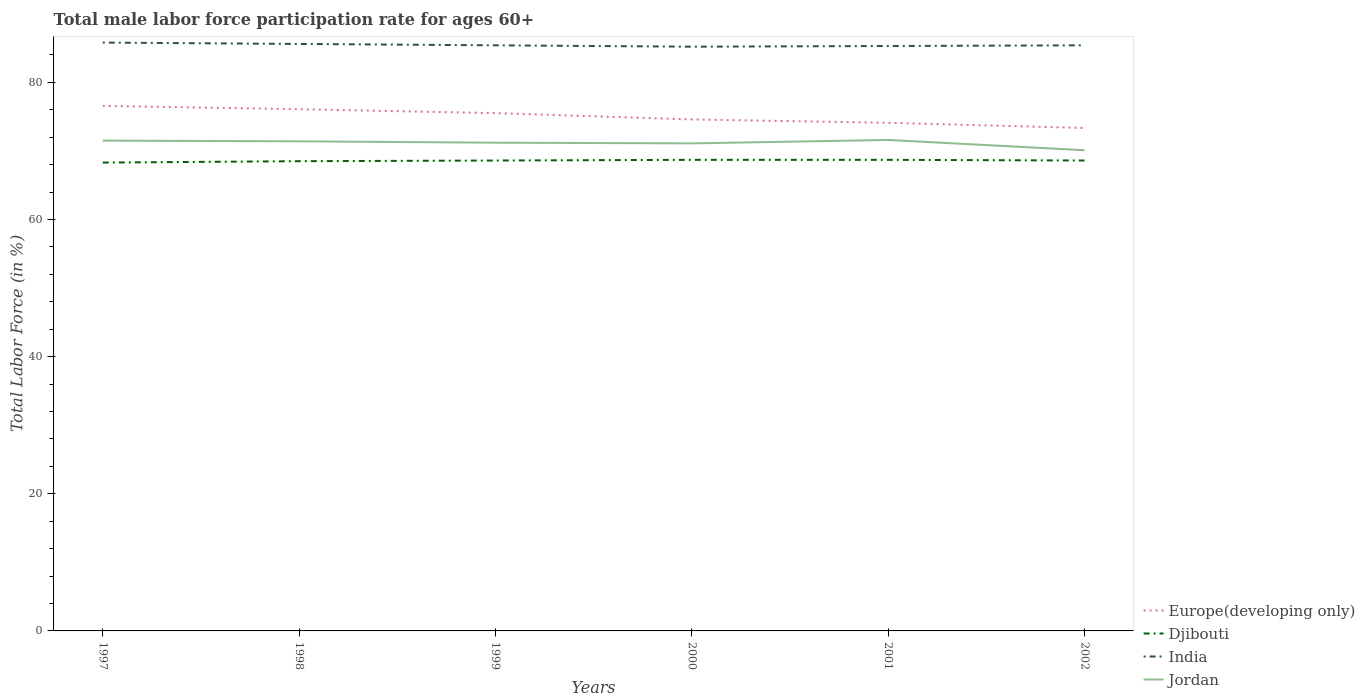How many different coloured lines are there?
Your answer should be compact. 4. Is the number of lines equal to the number of legend labels?
Provide a succinct answer. Yes. Across all years, what is the maximum male labor force participation rate in India?
Give a very brief answer. 85.2. In which year was the male labor force participation rate in Djibouti maximum?
Give a very brief answer. 1997. What is the total male labor force participation rate in Djibouti in the graph?
Provide a succinct answer. -0.1. What is the difference between the highest and the second highest male labor force participation rate in India?
Provide a short and direct response. 0.6. How many lines are there?
Give a very brief answer. 4. How many years are there in the graph?
Offer a very short reply. 6. Are the values on the major ticks of Y-axis written in scientific E-notation?
Your answer should be very brief. No. Does the graph contain any zero values?
Provide a short and direct response. No. Does the graph contain grids?
Provide a short and direct response. No. Where does the legend appear in the graph?
Ensure brevity in your answer.  Bottom right. What is the title of the graph?
Offer a terse response. Total male labor force participation rate for ages 60+. What is the label or title of the X-axis?
Offer a terse response. Years. What is the Total Labor Force (in %) of Europe(developing only) in 1997?
Keep it short and to the point. 76.57. What is the Total Labor Force (in %) of Djibouti in 1997?
Keep it short and to the point. 68.3. What is the Total Labor Force (in %) in India in 1997?
Your answer should be very brief. 85.8. What is the Total Labor Force (in %) of Jordan in 1997?
Your answer should be compact. 71.5. What is the Total Labor Force (in %) of Europe(developing only) in 1998?
Your answer should be very brief. 76.08. What is the Total Labor Force (in %) of Djibouti in 1998?
Provide a succinct answer. 68.5. What is the Total Labor Force (in %) in India in 1998?
Make the answer very short. 85.6. What is the Total Labor Force (in %) in Jordan in 1998?
Keep it short and to the point. 71.4. What is the Total Labor Force (in %) of Europe(developing only) in 1999?
Provide a succinct answer. 75.51. What is the Total Labor Force (in %) of Djibouti in 1999?
Your response must be concise. 68.6. What is the Total Labor Force (in %) of India in 1999?
Provide a succinct answer. 85.4. What is the Total Labor Force (in %) in Jordan in 1999?
Keep it short and to the point. 71.2. What is the Total Labor Force (in %) in Europe(developing only) in 2000?
Your response must be concise. 74.59. What is the Total Labor Force (in %) in Djibouti in 2000?
Your response must be concise. 68.7. What is the Total Labor Force (in %) of India in 2000?
Make the answer very short. 85.2. What is the Total Labor Force (in %) in Jordan in 2000?
Your answer should be very brief. 71.1. What is the Total Labor Force (in %) of Europe(developing only) in 2001?
Make the answer very short. 74.1. What is the Total Labor Force (in %) of Djibouti in 2001?
Provide a short and direct response. 68.7. What is the Total Labor Force (in %) in India in 2001?
Offer a very short reply. 85.3. What is the Total Labor Force (in %) in Jordan in 2001?
Ensure brevity in your answer.  71.6. What is the Total Labor Force (in %) in Europe(developing only) in 2002?
Give a very brief answer. 73.34. What is the Total Labor Force (in %) in Djibouti in 2002?
Your answer should be compact. 68.6. What is the Total Labor Force (in %) of India in 2002?
Your answer should be very brief. 85.4. What is the Total Labor Force (in %) of Jordan in 2002?
Provide a short and direct response. 70.1. Across all years, what is the maximum Total Labor Force (in %) in Europe(developing only)?
Provide a short and direct response. 76.57. Across all years, what is the maximum Total Labor Force (in %) of Djibouti?
Offer a very short reply. 68.7. Across all years, what is the maximum Total Labor Force (in %) of India?
Offer a very short reply. 85.8. Across all years, what is the maximum Total Labor Force (in %) of Jordan?
Your answer should be very brief. 71.6. Across all years, what is the minimum Total Labor Force (in %) in Europe(developing only)?
Make the answer very short. 73.34. Across all years, what is the minimum Total Labor Force (in %) of Djibouti?
Offer a very short reply. 68.3. Across all years, what is the minimum Total Labor Force (in %) in India?
Provide a succinct answer. 85.2. Across all years, what is the minimum Total Labor Force (in %) in Jordan?
Offer a very short reply. 70.1. What is the total Total Labor Force (in %) of Europe(developing only) in the graph?
Your answer should be very brief. 450.2. What is the total Total Labor Force (in %) in Djibouti in the graph?
Your answer should be compact. 411.4. What is the total Total Labor Force (in %) of India in the graph?
Your answer should be compact. 512.7. What is the total Total Labor Force (in %) of Jordan in the graph?
Provide a short and direct response. 426.9. What is the difference between the Total Labor Force (in %) in Europe(developing only) in 1997 and that in 1998?
Offer a very short reply. 0.48. What is the difference between the Total Labor Force (in %) in India in 1997 and that in 1998?
Provide a short and direct response. 0.2. What is the difference between the Total Labor Force (in %) in Europe(developing only) in 1997 and that in 1999?
Offer a very short reply. 1.05. What is the difference between the Total Labor Force (in %) in Djibouti in 1997 and that in 1999?
Give a very brief answer. -0.3. What is the difference between the Total Labor Force (in %) in Jordan in 1997 and that in 1999?
Make the answer very short. 0.3. What is the difference between the Total Labor Force (in %) in Europe(developing only) in 1997 and that in 2000?
Provide a succinct answer. 1.98. What is the difference between the Total Labor Force (in %) in Europe(developing only) in 1997 and that in 2001?
Your answer should be very brief. 2.47. What is the difference between the Total Labor Force (in %) in Djibouti in 1997 and that in 2001?
Provide a short and direct response. -0.4. What is the difference between the Total Labor Force (in %) in India in 1997 and that in 2001?
Make the answer very short. 0.5. What is the difference between the Total Labor Force (in %) in Jordan in 1997 and that in 2001?
Your answer should be very brief. -0.1. What is the difference between the Total Labor Force (in %) in Europe(developing only) in 1997 and that in 2002?
Offer a very short reply. 3.22. What is the difference between the Total Labor Force (in %) of Jordan in 1997 and that in 2002?
Offer a very short reply. 1.4. What is the difference between the Total Labor Force (in %) in Europe(developing only) in 1998 and that in 1999?
Your answer should be compact. 0.57. What is the difference between the Total Labor Force (in %) in Djibouti in 1998 and that in 1999?
Your answer should be very brief. -0.1. What is the difference between the Total Labor Force (in %) in India in 1998 and that in 1999?
Provide a short and direct response. 0.2. What is the difference between the Total Labor Force (in %) of Europe(developing only) in 1998 and that in 2000?
Make the answer very short. 1.49. What is the difference between the Total Labor Force (in %) in India in 1998 and that in 2000?
Give a very brief answer. 0.4. What is the difference between the Total Labor Force (in %) in Jordan in 1998 and that in 2000?
Offer a very short reply. 0.3. What is the difference between the Total Labor Force (in %) of Europe(developing only) in 1998 and that in 2001?
Ensure brevity in your answer.  1.98. What is the difference between the Total Labor Force (in %) in Djibouti in 1998 and that in 2001?
Your answer should be very brief. -0.2. What is the difference between the Total Labor Force (in %) in India in 1998 and that in 2001?
Provide a succinct answer. 0.3. What is the difference between the Total Labor Force (in %) of Jordan in 1998 and that in 2001?
Provide a succinct answer. -0.2. What is the difference between the Total Labor Force (in %) of Europe(developing only) in 1998 and that in 2002?
Offer a terse response. 2.74. What is the difference between the Total Labor Force (in %) in Djibouti in 1998 and that in 2002?
Provide a short and direct response. -0.1. What is the difference between the Total Labor Force (in %) of India in 1998 and that in 2002?
Keep it short and to the point. 0.2. What is the difference between the Total Labor Force (in %) of Europe(developing only) in 1999 and that in 2000?
Ensure brevity in your answer.  0.92. What is the difference between the Total Labor Force (in %) of Jordan in 1999 and that in 2000?
Offer a very short reply. 0.1. What is the difference between the Total Labor Force (in %) of Europe(developing only) in 1999 and that in 2001?
Make the answer very short. 1.41. What is the difference between the Total Labor Force (in %) in India in 1999 and that in 2001?
Give a very brief answer. 0.1. What is the difference between the Total Labor Force (in %) of Jordan in 1999 and that in 2001?
Your answer should be very brief. -0.4. What is the difference between the Total Labor Force (in %) in Europe(developing only) in 1999 and that in 2002?
Give a very brief answer. 2.17. What is the difference between the Total Labor Force (in %) in India in 1999 and that in 2002?
Provide a succinct answer. 0. What is the difference between the Total Labor Force (in %) of Europe(developing only) in 2000 and that in 2001?
Keep it short and to the point. 0.49. What is the difference between the Total Labor Force (in %) in Djibouti in 2000 and that in 2001?
Your answer should be very brief. 0. What is the difference between the Total Labor Force (in %) in India in 2000 and that in 2001?
Provide a succinct answer. -0.1. What is the difference between the Total Labor Force (in %) in Europe(developing only) in 2000 and that in 2002?
Offer a terse response. 1.25. What is the difference between the Total Labor Force (in %) of Jordan in 2000 and that in 2002?
Your answer should be very brief. 1. What is the difference between the Total Labor Force (in %) of Europe(developing only) in 2001 and that in 2002?
Provide a succinct answer. 0.75. What is the difference between the Total Labor Force (in %) in Djibouti in 2001 and that in 2002?
Your answer should be compact. 0.1. What is the difference between the Total Labor Force (in %) of India in 2001 and that in 2002?
Ensure brevity in your answer.  -0.1. What is the difference between the Total Labor Force (in %) of Europe(developing only) in 1997 and the Total Labor Force (in %) of Djibouti in 1998?
Your response must be concise. 8.07. What is the difference between the Total Labor Force (in %) of Europe(developing only) in 1997 and the Total Labor Force (in %) of India in 1998?
Offer a very short reply. -9.03. What is the difference between the Total Labor Force (in %) of Europe(developing only) in 1997 and the Total Labor Force (in %) of Jordan in 1998?
Offer a terse response. 5.17. What is the difference between the Total Labor Force (in %) in Djibouti in 1997 and the Total Labor Force (in %) in India in 1998?
Your answer should be very brief. -17.3. What is the difference between the Total Labor Force (in %) in Djibouti in 1997 and the Total Labor Force (in %) in Jordan in 1998?
Offer a terse response. -3.1. What is the difference between the Total Labor Force (in %) of Europe(developing only) in 1997 and the Total Labor Force (in %) of Djibouti in 1999?
Provide a succinct answer. 7.97. What is the difference between the Total Labor Force (in %) in Europe(developing only) in 1997 and the Total Labor Force (in %) in India in 1999?
Keep it short and to the point. -8.83. What is the difference between the Total Labor Force (in %) in Europe(developing only) in 1997 and the Total Labor Force (in %) in Jordan in 1999?
Provide a short and direct response. 5.37. What is the difference between the Total Labor Force (in %) in Djibouti in 1997 and the Total Labor Force (in %) in India in 1999?
Your answer should be very brief. -17.1. What is the difference between the Total Labor Force (in %) of India in 1997 and the Total Labor Force (in %) of Jordan in 1999?
Keep it short and to the point. 14.6. What is the difference between the Total Labor Force (in %) of Europe(developing only) in 1997 and the Total Labor Force (in %) of Djibouti in 2000?
Ensure brevity in your answer.  7.87. What is the difference between the Total Labor Force (in %) in Europe(developing only) in 1997 and the Total Labor Force (in %) in India in 2000?
Keep it short and to the point. -8.63. What is the difference between the Total Labor Force (in %) in Europe(developing only) in 1997 and the Total Labor Force (in %) in Jordan in 2000?
Offer a very short reply. 5.47. What is the difference between the Total Labor Force (in %) of Djibouti in 1997 and the Total Labor Force (in %) of India in 2000?
Your response must be concise. -16.9. What is the difference between the Total Labor Force (in %) of Djibouti in 1997 and the Total Labor Force (in %) of Jordan in 2000?
Offer a very short reply. -2.8. What is the difference between the Total Labor Force (in %) of Europe(developing only) in 1997 and the Total Labor Force (in %) of Djibouti in 2001?
Make the answer very short. 7.87. What is the difference between the Total Labor Force (in %) in Europe(developing only) in 1997 and the Total Labor Force (in %) in India in 2001?
Your response must be concise. -8.73. What is the difference between the Total Labor Force (in %) of Europe(developing only) in 1997 and the Total Labor Force (in %) of Jordan in 2001?
Your answer should be compact. 4.97. What is the difference between the Total Labor Force (in %) of Europe(developing only) in 1997 and the Total Labor Force (in %) of Djibouti in 2002?
Your response must be concise. 7.97. What is the difference between the Total Labor Force (in %) in Europe(developing only) in 1997 and the Total Labor Force (in %) in India in 2002?
Provide a short and direct response. -8.83. What is the difference between the Total Labor Force (in %) of Europe(developing only) in 1997 and the Total Labor Force (in %) of Jordan in 2002?
Keep it short and to the point. 6.47. What is the difference between the Total Labor Force (in %) in Djibouti in 1997 and the Total Labor Force (in %) in India in 2002?
Ensure brevity in your answer.  -17.1. What is the difference between the Total Labor Force (in %) of India in 1997 and the Total Labor Force (in %) of Jordan in 2002?
Your response must be concise. 15.7. What is the difference between the Total Labor Force (in %) of Europe(developing only) in 1998 and the Total Labor Force (in %) of Djibouti in 1999?
Ensure brevity in your answer.  7.48. What is the difference between the Total Labor Force (in %) in Europe(developing only) in 1998 and the Total Labor Force (in %) in India in 1999?
Your response must be concise. -9.32. What is the difference between the Total Labor Force (in %) in Europe(developing only) in 1998 and the Total Labor Force (in %) in Jordan in 1999?
Your answer should be compact. 4.88. What is the difference between the Total Labor Force (in %) of Djibouti in 1998 and the Total Labor Force (in %) of India in 1999?
Give a very brief answer. -16.9. What is the difference between the Total Labor Force (in %) in Djibouti in 1998 and the Total Labor Force (in %) in Jordan in 1999?
Your response must be concise. -2.7. What is the difference between the Total Labor Force (in %) of India in 1998 and the Total Labor Force (in %) of Jordan in 1999?
Keep it short and to the point. 14.4. What is the difference between the Total Labor Force (in %) in Europe(developing only) in 1998 and the Total Labor Force (in %) in Djibouti in 2000?
Give a very brief answer. 7.38. What is the difference between the Total Labor Force (in %) in Europe(developing only) in 1998 and the Total Labor Force (in %) in India in 2000?
Your answer should be compact. -9.12. What is the difference between the Total Labor Force (in %) of Europe(developing only) in 1998 and the Total Labor Force (in %) of Jordan in 2000?
Provide a succinct answer. 4.98. What is the difference between the Total Labor Force (in %) of Djibouti in 1998 and the Total Labor Force (in %) of India in 2000?
Ensure brevity in your answer.  -16.7. What is the difference between the Total Labor Force (in %) of Djibouti in 1998 and the Total Labor Force (in %) of Jordan in 2000?
Offer a very short reply. -2.6. What is the difference between the Total Labor Force (in %) in Europe(developing only) in 1998 and the Total Labor Force (in %) in Djibouti in 2001?
Give a very brief answer. 7.38. What is the difference between the Total Labor Force (in %) of Europe(developing only) in 1998 and the Total Labor Force (in %) of India in 2001?
Provide a short and direct response. -9.22. What is the difference between the Total Labor Force (in %) of Europe(developing only) in 1998 and the Total Labor Force (in %) of Jordan in 2001?
Give a very brief answer. 4.48. What is the difference between the Total Labor Force (in %) in Djibouti in 1998 and the Total Labor Force (in %) in India in 2001?
Your response must be concise. -16.8. What is the difference between the Total Labor Force (in %) of Djibouti in 1998 and the Total Labor Force (in %) of Jordan in 2001?
Make the answer very short. -3.1. What is the difference between the Total Labor Force (in %) in India in 1998 and the Total Labor Force (in %) in Jordan in 2001?
Provide a short and direct response. 14. What is the difference between the Total Labor Force (in %) in Europe(developing only) in 1998 and the Total Labor Force (in %) in Djibouti in 2002?
Your answer should be very brief. 7.48. What is the difference between the Total Labor Force (in %) of Europe(developing only) in 1998 and the Total Labor Force (in %) of India in 2002?
Your answer should be compact. -9.32. What is the difference between the Total Labor Force (in %) of Europe(developing only) in 1998 and the Total Labor Force (in %) of Jordan in 2002?
Give a very brief answer. 5.98. What is the difference between the Total Labor Force (in %) in Djibouti in 1998 and the Total Labor Force (in %) in India in 2002?
Your answer should be compact. -16.9. What is the difference between the Total Labor Force (in %) in Djibouti in 1998 and the Total Labor Force (in %) in Jordan in 2002?
Your answer should be very brief. -1.6. What is the difference between the Total Labor Force (in %) of Europe(developing only) in 1999 and the Total Labor Force (in %) of Djibouti in 2000?
Your response must be concise. 6.81. What is the difference between the Total Labor Force (in %) in Europe(developing only) in 1999 and the Total Labor Force (in %) in India in 2000?
Provide a short and direct response. -9.69. What is the difference between the Total Labor Force (in %) of Europe(developing only) in 1999 and the Total Labor Force (in %) of Jordan in 2000?
Your response must be concise. 4.41. What is the difference between the Total Labor Force (in %) of Djibouti in 1999 and the Total Labor Force (in %) of India in 2000?
Your answer should be very brief. -16.6. What is the difference between the Total Labor Force (in %) of Djibouti in 1999 and the Total Labor Force (in %) of Jordan in 2000?
Ensure brevity in your answer.  -2.5. What is the difference between the Total Labor Force (in %) in Europe(developing only) in 1999 and the Total Labor Force (in %) in Djibouti in 2001?
Give a very brief answer. 6.81. What is the difference between the Total Labor Force (in %) in Europe(developing only) in 1999 and the Total Labor Force (in %) in India in 2001?
Keep it short and to the point. -9.79. What is the difference between the Total Labor Force (in %) in Europe(developing only) in 1999 and the Total Labor Force (in %) in Jordan in 2001?
Offer a very short reply. 3.91. What is the difference between the Total Labor Force (in %) in Djibouti in 1999 and the Total Labor Force (in %) in India in 2001?
Keep it short and to the point. -16.7. What is the difference between the Total Labor Force (in %) in Europe(developing only) in 1999 and the Total Labor Force (in %) in Djibouti in 2002?
Ensure brevity in your answer.  6.91. What is the difference between the Total Labor Force (in %) of Europe(developing only) in 1999 and the Total Labor Force (in %) of India in 2002?
Offer a terse response. -9.89. What is the difference between the Total Labor Force (in %) in Europe(developing only) in 1999 and the Total Labor Force (in %) in Jordan in 2002?
Your answer should be very brief. 5.41. What is the difference between the Total Labor Force (in %) of Djibouti in 1999 and the Total Labor Force (in %) of India in 2002?
Your answer should be very brief. -16.8. What is the difference between the Total Labor Force (in %) of Djibouti in 1999 and the Total Labor Force (in %) of Jordan in 2002?
Keep it short and to the point. -1.5. What is the difference between the Total Labor Force (in %) of India in 1999 and the Total Labor Force (in %) of Jordan in 2002?
Provide a succinct answer. 15.3. What is the difference between the Total Labor Force (in %) of Europe(developing only) in 2000 and the Total Labor Force (in %) of Djibouti in 2001?
Provide a short and direct response. 5.89. What is the difference between the Total Labor Force (in %) of Europe(developing only) in 2000 and the Total Labor Force (in %) of India in 2001?
Provide a succinct answer. -10.71. What is the difference between the Total Labor Force (in %) in Europe(developing only) in 2000 and the Total Labor Force (in %) in Jordan in 2001?
Offer a very short reply. 2.99. What is the difference between the Total Labor Force (in %) of Djibouti in 2000 and the Total Labor Force (in %) of India in 2001?
Your response must be concise. -16.6. What is the difference between the Total Labor Force (in %) in Djibouti in 2000 and the Total Labor Force (in %) in Jordan in 2001?
Offer a terse response. -2.9. What is the difference between the Total Labor Force (in %) of Europe(developing only) in 2000 and the Total Labor Force (in %) of Djibouti in 2002?
Offer a very short reply. 5.99. What is the difference between the Total Labor Force (in %) of Europe(developing only) in 2000 and the Total Labor Force (in %) of India in 2002?
Your response must be concise. -10.81. What is the difference between the Total Labor Force (in %) in Europe(developing only) in 2000 and the Total Labor Force (in %) in Jordan in 2002?
Your response must be concise. 4.49. What is the difference between the Total Labor Force (in %) in Djibouti in 2000 and the Total Labor Force (in %) in India in 2002?
Your answer should be compact. -16.7. What is the difference between the Total Labor Force (in %) of Europe(developing only) in 2001 and the Total Labor Force (in %) of Djibouti in 2002?
Keep it short and to the point. 5.5. What is the difference between the Total Labor Force (in %) of Europe(developing only) in 2001 and the Total Labor Force (in %) of India in 2002?
Offer a very short reply. -11.3. What is the difference between the Total Labor Force (in %) of Europe(developing only) in 2001 and the Total Labor Force (in %) of Jordan in 2002?
Keep it short and to the point. 4. What is the difference between the Total Labor Force (in %) of Djibouti in 2001 and the Total Labor Force (in %) of India in 2002?
Give a very brief answer. -16.7. What is the difference between the Total Labor Force (in %) of India in 2001 and the Total Labor Force (in %) of Jordan in 2002?
Give a very brief answer. 15.2. What is the average Total Labor Force (in %) of Europe(developing only) per year?
Offer a very short reply. 75.03. What is the average Total Labor Force (in %) of Djibouti per year?
Give a very brief answer. 68.57. What is the average Total Labor Force (in %) of India per year?
Provide a short and direct response. 85.45. What is the average Total Labor Force (in %) in Jordan per year?
Make the answer very short. 71.15. In the year 1997, what is the difference between the Total Labor Force (in %) in Europe(developing only) and Total Labor Force (in %) in Djibouti?
Keep it short and to the point. 8.27. In the year 1997, what is the difference between the Total Labor Force (in %) in Europe(developing only) and Total Labor Force (in %) in India?
Your answer should be very brief. -9.23. In the year 1997, what is the difference between the Total Labor Force (in %) in Europe(developing only) and Total Labor Force (in %) in Jordan?
Keep it short and to the point. 5.07. In the year 1997, what is the difference between the Total Labor Force (in %) in Djibouti and Total Labor Force (in %) in India?
Ensure brevity in your answer.  -17.5. In the year 1997, what is the difference between the Total Labor Force (in %) of Djibouti and Total Labor Force (in %) of Jordan?
Your answer should be compact. -3.2. In the year 1998, what is the difference between the Total Labor Force (in %) of Europe(developing only) and Total Labor Force (in %) of Djibouti?
Make the answer very short. 7.58. In the year 1998, what is the difference between the Total Labor Force (in %) in Europe(developing only) and Total Labor Force (in %) in India?
Offer a terse response. -9.52. In the year 1998, what is the difference between the Total Labor Force (in %) in Europe(developing only) and Total Labor Force (in %) in Jordan?
Provide a short and direct response. 4.68. In the year 1998, what is the difference between the Total Labor Force (in %) in Djibouti and Total Labor Force (in %) in India?
Your answer should be very brief. -17.1. In the year 1998, what is the difference between the Total Labor Force (in %) in India and Total Labor Force (in %) in Jordan?
Keep it short and to the point. 14.2. In the year 1999, what is the difference between the Total Labor Force (in %) of Europe(developing only) and Total Labor Force (in %) of Djibouti?
Keep it short and to the point. 6.91. In the year 1999, what is the difference between the Total Labor Force (in %) of Europe(developing only) and Total Labor Force (in %) of India?
Offer a terse response. -9.89. In the year 1999, what is the difference between the Total Labor Force (in %) of Europe(developing only) and Total Labor Force (in %) of Jordan?
Provide a succinct answer. 4.31. In the year 1999, what is the difference between the Total Labor Force (in %) in Djibouti and Total Labor Force (in %) in India?
Ensure brevity in your answer.  -16.8. In the year 2000, what is the difference between the Total Labor Force (in %) of Europe(developing only) and Total Labor Force (in %) of Djibouti?
Your response must be concise. 5.89. In the year 2000, what is the difference between the Total Labor Force (in %) of Europe(developing only) and Total Labor Force (in %) of India?
Offer a very short reply. -10.61. In the year 2000, what is the difference between the Total Labor Force (in %) of Europe(developing only) and Total Labor Force (in %) of Jordan?
Offer a very short reply. 3.49. In the year 2000, what is the difference between the Total Labor Force (in %) in Djibouti and Total Labor Force (in %) in India?
Offer a terse response. -16.5. In the year 2000, what is the difference between the Total Labor Force (in %) of Djibouti and Total Labor Force (in %) of Jordan?
Keep it short and to the point. -2.4. In the year 2000, what is the difference between the Total Labor Force (in %) of India and Total Labor Force (in %) of Jordan?
Offer a terse response. 14.1. In the year 2001, what is the difference between the Total Labor Force (in %) of Europe(developing only) and Total Labor Force (in %) of Djibouti?
Keep it short and to the point. 5.4. In the year 2001, what is the difference between the Total Labor Force (in %) in Europe(developing only) and Total Labor Force (in %) in India?
Ensure brevity in your answer.  -11.2. In the year 2001, what is the difference between the Total Labor Force (in %) in Europe(developing only) and Total Labor Force (in %) in Jordan?
Ensure brevity in your answer.  2.5. In the year 2001, what is the difference between the Total Labor Force (in %) of Djibouti and Total Labor Force (in %) of India?
Offer a terse response. -16.6. In the year 2001, what is the difference between the Total Labor Force (in %) of India and Total Labor Force (in %) of Jordan?
Your response must be concise. 13.7. In the year 2002, what is the difference between the Total Labor Force (in %) in Europe(developing only) and Total Labor Force (in %) in Djibouti?
Provide a short and direct response. 4.74. In the year 2002, what is the difference between the Total Labor Force (in %) in Europe(developing only) and Total Labor Force (in %) in India?
Provide a short and direct response. -12.06. In the year 2002, what is the difference between the Total Labor Force (in %) in Europe(developing only) and Total Labor Force (in %) in Jordan?
Offer a terse response. 3.24. In the year 2002, what is the difference between the Total Labor Force (in %) of Djibouti and Total Labor Force (in %) of India?
Your response must be concise. -16.8. What is the ratio of the Total Labor Force (in %) of Europe(developing only) in 1997 to that in 1998?
Give a very brief answer. 1.01. What is the ratio of the Total Labor Force (in %) of India in 1997 to that in 1998?
Ensure brevity in your answer.  1. What is the ratio of the Total Labor Force (in %) of Jordan in 1997 to that in 1998?
Keep it short and to the point. 1. What is the ratio of the Total Labor Force (in %) of Europe(developing only) in 1997 to that in 1999?
Your answer should be compact. 1.01. What is the ratio of the Total Labor Force (in %) in India in 1997 to that in 1999?
Your answer should be very brief. 1. What is the ratio of the Total Labor Force (in %) in Jordan in 1997 to that in 1999?
Offer a very short reply. 1. What is the ratio of the Total Labor Force (in %) in Europe(developing only) in 1997 to that in 2000?
Keep it short and to the point. 1.03. What is the ratio of the Total Labor Force (in %) of Djibouti in 1997 to that in 2000?
Your answer should be very brief. 0.99. What is the ratio of the Total Labor Force (in %) in Jordan in 1997 to that in 2000?
Offer a terse response. 1.01. What is the ratio of the Total Labor Force (in %) in India in 1997 to that in 2001?
Offer a terse response. 1.01. What is the ratio of the Total Labor Force (in %) of Europe(developing only) in 1997 to that in 2002?
Offer a very short reply. 1.04. What is the ratio of the Total Labor Force (in %) in Djibouti in 1997 to that in 2002?
Your answer should be very brief. 1. What is the ratio of the Total Labor Force (in %) in Jordan in 1997 to that in 2002?
Provide a short and direct response. 1.02. What is the ratio of the Total Labor Force (in %) in Europe(developing only) in 1998 to that in 1999?
Your response must be concise. 1.01. What is the ratio of the Total Labor Force (in %) of Djibouti in 1998 to that in 1999?
Ensure brevity in your answer.  1. What is the ratio of the Total Labor Force (in %) in India in 1998 to that in 1999?
Offer a terse response. 1. What is the ratio of the Total Labor Force (in %) in Jordan in 1998 to that in 1999?
Offer a terse response. 1. What is the ratio of the Total Labor Force (in %) in Europe(developing only) in 1998 to that in 2001?
Keep it short and to the point. 1.03. What is the ratio of the Total Labor Force (in %) in Djibouti in 1998 to that in 2001?
Provide a short and direct response. 1. What is the ratio of the Total Labor Force (in %) in Europe(developing only) in 1998 to that in 2002?
Provide a succinct answer. 1.04. What is the ratio of the Total Labor Force (in %) in India in 1998 to that in 2002?
Your response must be concise. 1. What is the ratio of the Total Labor Force (in %) in Jordan in 1998 to that in 2002?
Offer a terse response. 1.02. What is the ratio of the Total Labor Force (in %) of Europe(developing only) in 1999 to that in 2000?
Offer a terse response. 1.01. What is the ratio of the Total Labor Force (in %) of Djibouti in 1999 to that in 2000?
Your answer should be very brief. 1. What is the ratio of the Total Labor Force (in %) in India in 1999 to that in 2000?
Provide a succinct answer. 1. What is the ratio of the Total Labor Force (in %) in Europe(developing only) in 1999 to that in 2001?
Provide a short and direct response. 1.02. What is the ratio of the Total Labor Force (in %) of Jordan in 1999 to that in 2001?
Offer a terse response. 0.99. What is the ratio of the Total Labor Force (in %) in Europe(developing only) in 1999 to that in 2002?
Your answer should be very brief. 1.03. What is the ratio of the Total Labor Force (in %) of Djibouti in 1999 to that in 2002?
Your answer should be very brief. 1. What is the ratio of the Total Labor Force (in %) in Jordan in 1999 to that in 2002?
Offer a very short reply. 1.02. What is the ratio of the Total Labor Force (in %) in Europe(developing only) in 2000 to that in 2001?
Give a very brief answer. 1.01. What is the ratio of the Total Labor Force (in %) in Djibouti in 2000 to that in 2001?
Offer a very short reply. 1. What is the ratio of the Total Labor Force (in %) of India in 2000 to that in 2001?
Keep it short and to the point. 1. What is the ratio of the Total Labor Force (in %) in India in 2000 to that in 2002?
Give a very brief answer. 1. What is the ratio of the Total Labor Force (in %) in Jordan in 2000 to that in 2002?
Keep it short and to the point. 1.01. What is the ratio of the Total Labor Force (in %) in Europe(developing only) in 2001 to that in 2002?
Provide a succinct answer. 1.01. What is the ratio of the Total Labor Force (in %) of Djibouti in 2001 to that in 2002?
Your answer should be very brief. 1. What is the ratio of the Total Labor Force (in %) in Jordan in 2001 to that in 2002?
Your answer should be compact. 1.02. What is the difference between the highest and the second highest Total Labor Force (in %) in Europe(developing only)?
Provide a succinct answer. 0.48. What is the difference between the highest and the second highest Total Labor Force (in %) of Djibouti?
Your response must be concise. 0. What is the difference between the highest and the second highest Total Labor Force (in %) in India?
Give a very brief answer. 0.2. What is the difference between the highest and the lowest Total Labor Force (in %) of Europe(developing only)?
Ensure brevity in your answer.  3.22. What is the difference between the highest and the lowest Total Labor Force (in %) of Djibouti?
Offer a terse response. 0.4. What is the difference between the highest and the lowest Total Labor Force (in %) of Jordan?
Your answer should be very brief. 1.5. 